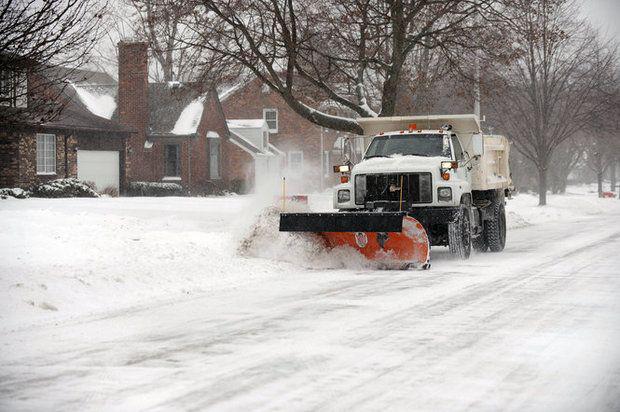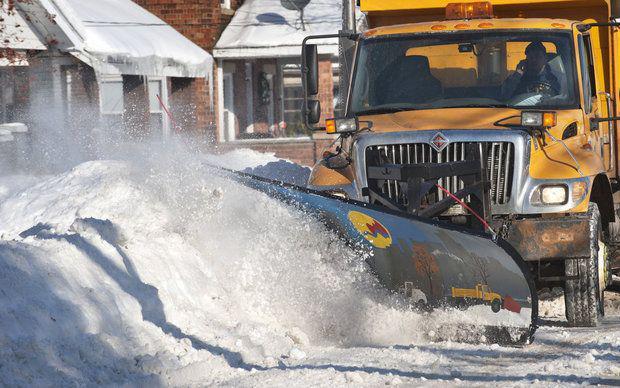The first image is the image on the left, the second image is the image on the right. Considering the images on both sides, is "Both plows are facing toward the bottom right and plowing snow." valid? Answer yes or no. Yes. The first image is the image on the left, the second image is the image on the right. Considering the images on both sides, is "The left and right image contains the same number of white and yellow snow plows." valid? Answer yes or no. Yes. 